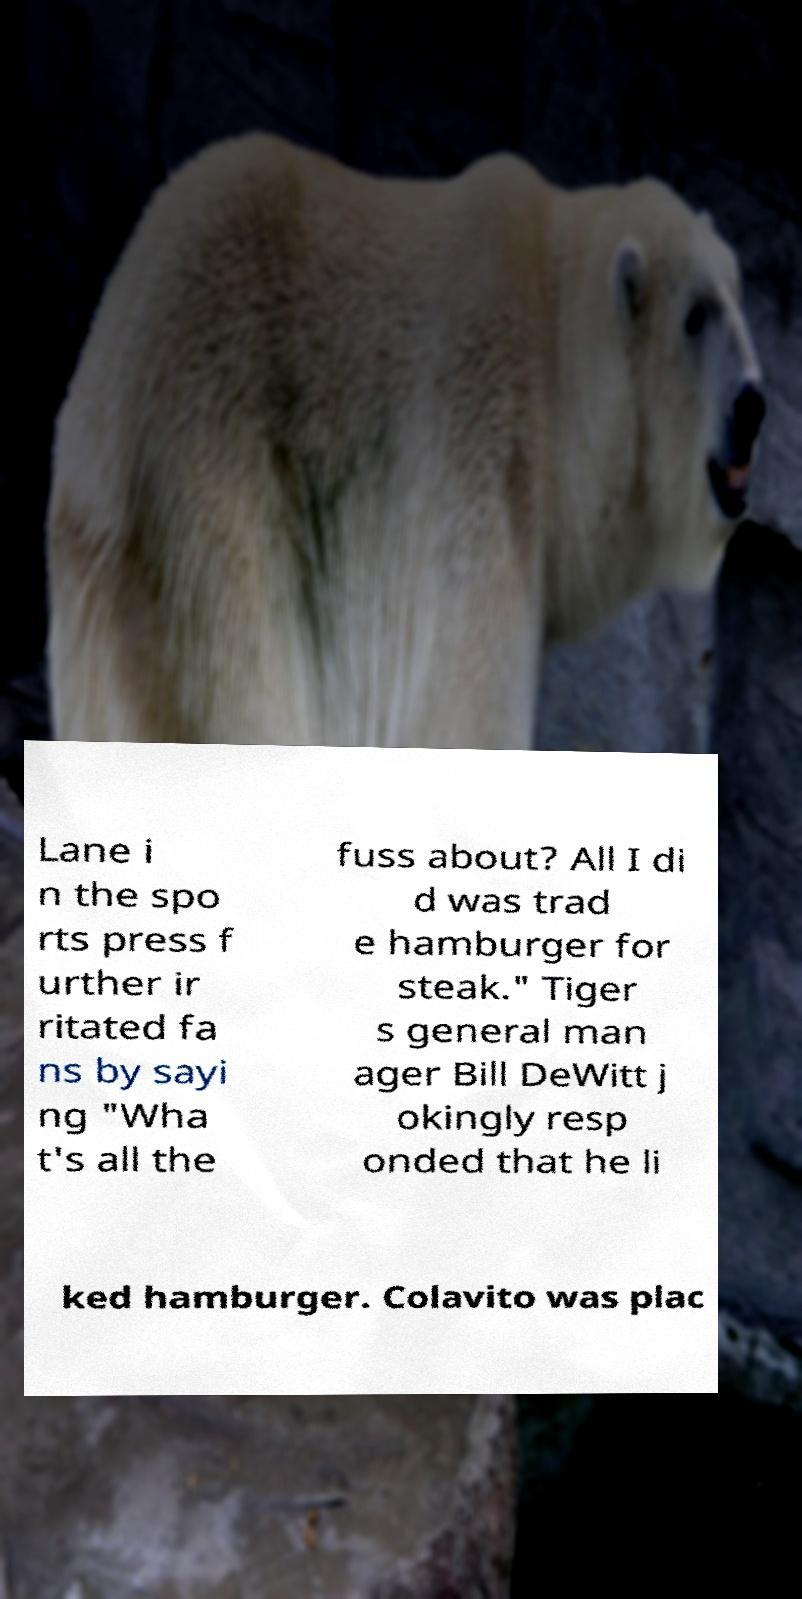Can you read and provide the text displayed in the image?This photo seems to have some interesting text. Can you extract and type it out for me? Lane i n the spo rts press f urther ir ritated fa ns by sayi ng "Wha t's all the fuss about? All I di d was trad e hamburger for steak." Tiger s general man ager Bill DeWitt j okingly resp onded that he li ked hamburger. Colavito was plac 